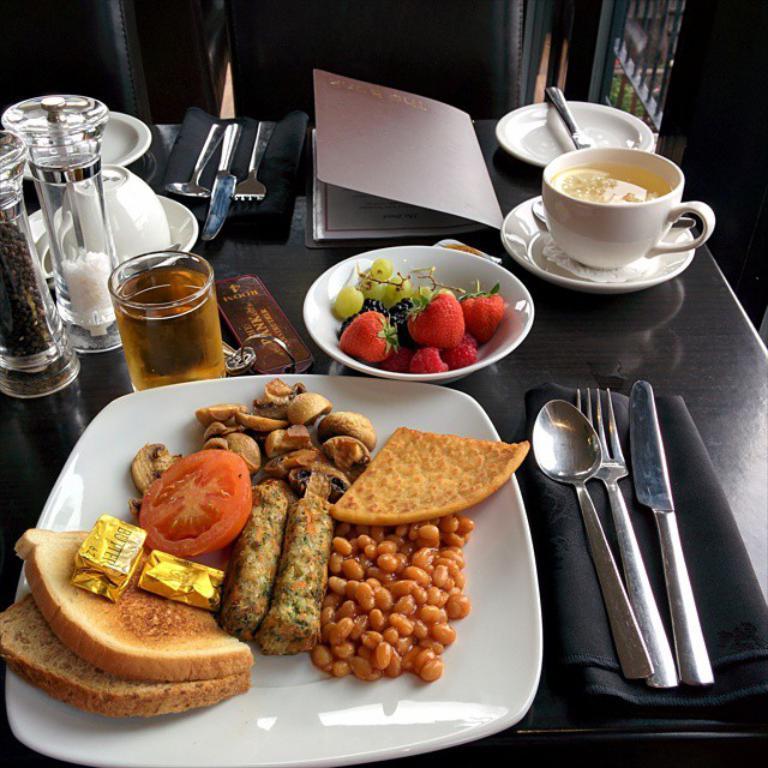Describe this image in one or two sentences. In this image we can see food on plate, fruits, cup, saucer, knife, fork, spoon, napkin, beverage in glass placed on the table. 